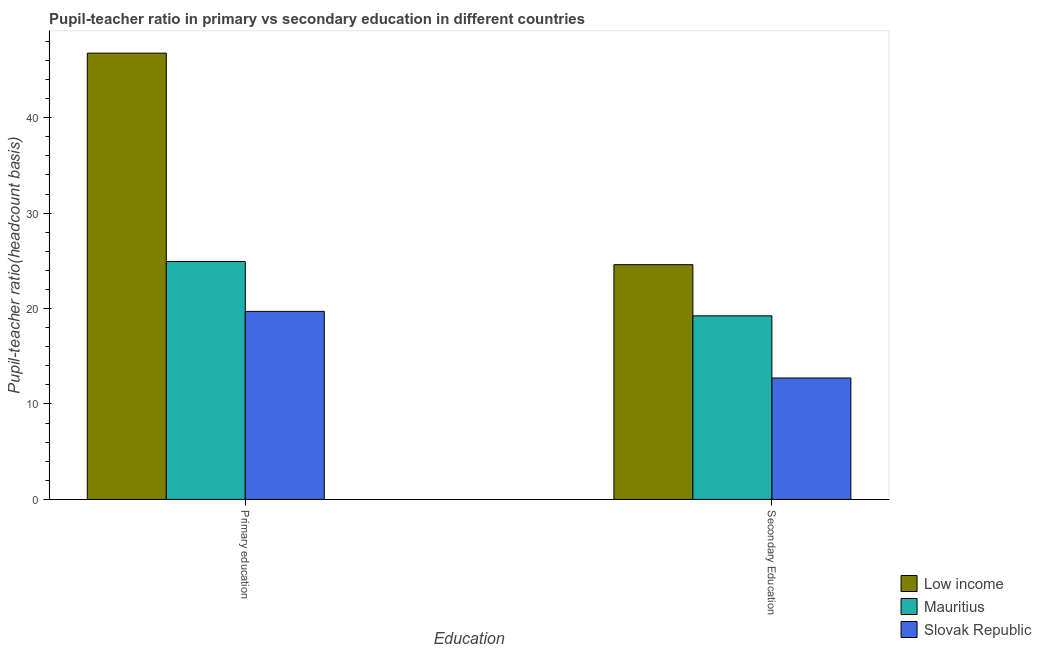How many groups of bars are there?
Provide a short and direct response. 2. Are the number of bars on each tick of the X-axis equal?
Your answer should be compact. Yes. How many bars are there on the 2nd tick from the right?
Your answer should be compact. 3. What is the label of the 2nd group of bars from the left?
Provide a succinct answer. Secondary Education. What is the pupil-teacher ratio in primary education in Slovak Republic?
Provide a succinct answer. 19.7. Across all countries, what is the maximum pupil-teacher ratio in primary education?
Give a very brief answer. 46.76. Across all countries, what is the minimum pupil-teacher ratio in primary education?
Give a very brief answer. 19.7. In which country was the pupil teacher ratio on secondary education maximum?
Make the answer very short. Low income. In which country was the pupil-teacher ratio in primary education minimum?
Ensure brevity in your answer.  Slovak Republic. What is the total pupil-teacher ratio in primary education in the graph?
Your answer should be compact. 91.39. What is the difference between the pupil teacher ratio on secondary education in Mauritius and that in Low income?
Make the answer very short. -5.36. What is the difference between the pupil teacher ratio on secondary education in Slovak Republic and the pupil-teacher ratio in primary education in Low income?
Your answer should be compact. -34.04. What is the average pupil-teacher ratio in primary education per country?
Offer a terse response. 30.46. What is the difference between the pupil teacher ratio on secondary education and pupil-teacher ratio in primary education in Low income?
Your answer should be very brief. -22.16. What is the ratio of the pupil teacher ratio on secondary education in Low income to that in Slovak Republic?
Your answer should be very brief. 1.93. Is the pupil-teacher ratio in primary education in Slovak Republic less than that in Low income?
Offer a terse response. Yes. What does the 1st bar from the right in Primary education represents?
Provide a succinct answer. Slovak Republic. How many countries are there in the graph?
Your response must be concise. 3. What is the difference between two consecutive major ticks on the Y-axis?
Your answer should be compact. 10. Does the graph contain any zero values?
Give a very brief answer. No. What is the title of the graph?
Keep it short and to the point. Pupil-teacher ratio in primary vs secondary education in different countries. Does "American Samoa" appear as one of the legend labels in the graph?
Your response must be concise. No. What is the label or title of the X-axis?
Give a very brief answer. Education. What is the label or title of the Y-axis?
Offer a very short reply. Pupil-teacher ratio(headcount basis). What is the Pupil-teacher ratio(headcount basis) in Low income in Primary education?
Offer a very short reply. 46.76. What is the Pupil-teacher ratio(headcount basis) in Mauritius in Primary education?
Make the answer very short. 24.93. What is the Pupil-teacher ratio(headcount basis) of Slovak Republic in Primary education?
Provide a short and direct response. 19.7. What is the Pupil-teacher ratio(headcount basis) of Low income in Secondary Education?
Provide a succinct answer. 24.6. What is the Pupil-teacher ratio(headcount basis) in Mauritius in Secondary Education?
Provide a succinct answer. 19.23. What is the Pupil-teacher ratio(headcount basis) in Slovak Republic in Secondary Education?
Your answer should be compact. 12.72. Across all Education, what is the maximum Pupil-teacher ratio(headcount basis) of Low income?
Offer a terse response. 46.76. Across all Education, what is the maximum Pupil-teacher ratio(headcount basis) of Mauritius?
Your answer should be very brief. 24.93. Across all Education, what is the maximum Pupil-teacher ratio(headcount basis) of Slovak Republic?
Your response must be concise. 19.7. Across all Education, what is the minimum Pupil-teacher ratio(headcount basis) of Low income?
Your answer should be very brief. 24.6. Across all Education, what is the minimum Pupil-teacher ratio(headcount basis) in Mauritius?
Offer a very short reply. 19.23. Across all Education, what is the minimum Pupil-teacher ratio(headcount basis) in Slovak Republic?
Your answer should be compact. 12.72. What is the total Pupil-teacher ratio(headcount basis) of Low income in the graph?
Give a very brief answer. 71.35. What is the total Pupil-teacher ratio(headcount basis) of Mauritius in the graph?
Offer a terse response. 44.16. What is the total Pupil-teacher ratio(headcount basis) in Slovak Republic in the graph?
Offer a very short reply. 32.43. What is the difference between the Pupil-teacher ratio(headcount basis) in Low income in Primary education and that in Secondary Education?
Provide a short and direct response. 22.16. What is the difference between the Pupil-teacher ratio(headcount basis) in Mauritius in Primary education and that in Secondary Education?
Your response must be concise. 5.69. What is the difference between the Pupil-teacher ratio(headcount basis) in Slovak Republic in Primary education and that in Secondary Education?
Your answer should be compact. 6.98. What is the difference between the Pupil-teacher ratio(headcount basis) in Low income in Primary education and the Pupil-teacher ratio(headcount basis) in Mauritius in Secondary Education?
Offer a terse response. 27.52. What is the difference between the Pupil-teacher ratio(headcount basis) in Low income in Primary education and the Pupil-teacher ratio(headcount basis) in Slovak Republic in Secondary Education?
Make the answer very short. 34.04. What is the difference between the Pupil-teacher ratio(headcount basis) in Mauritius in Primary education and the Pupil-teacher ratio(headcount basis) in Slovak Republic in Secondary Education?
Provide a succinct answer. 12.21. What is the average Pupil-teacher ratio(headcount basis) of Low income per Education?
Provide a succinct answer. 35.68. What is the average Pupil-teacher ratio(headcount basis) of Mauritius per Education?
Your answer should be compact. 22.08. What is the average Pupil-teacher ratio(headcount basis) in Slovak Republic per Education?
Ensure brevity in your answer.  16.21. What is the difference between the Pupil-teacher ratio(headcount basis) of Low income and Pupil-teacher ratio(headcount basis) of Mauritius in Primary education?
Offer a terse response. 21.83. What is the difference between the Pupil-teacher ratio(headcount basis) in Low income and Pupil-teacher ratio(headcount basis) in Slovak Republic in Primary education?
Give a very brief answer. 27.05. What is the difference between the Pupil-teacher ratio(headcount basis) in Mauritius and Pupil-teacher ratio(headcount basis) in Slovak Republic in Primary education?
Offer a terse response. 5.22. What is the difference between the Pupil-teacher ratio(headcount basis) of Low income and Pupil-teacher ratio(headcount basis) of Mauritius in Secondary Education?
Provide a short and direct response. 5.36. What is the difference between the Pupil-teacher ratio(headcount basis) in Low income and Pupil-teacher ratio(headcount basis) in Slovak Republic in Secondary Education?
Provide a short and direct response. 11.87. What is the difference between the Pupil-teacher ratio(headcount basis) in Mauritius and Pupil-teacher ratio(headcount basis) in Slovak Republic in Secondary Education?
Provide a succinct answer. 6.51. What is the ratio of the Pupil-teacher ratio(headcount basis) of Low income in Primary education to that in Secondary Education?
Provide a succinct answer. 1.9. What is the ratio of the Pupil-teacher ratio(headcount basis) in Mauritius in Primary education to that in Secondary Education?
Your response must be concise. 1.3. What is the ratio of the Pupil-teacher ratio(headcount basis) of Slovak Republic in Primary education to that in Secondary Education?
Your answer should be very brief. 1.55. What is the difference between the highest and the second highest Pupil-teacher ratio(headcount basis) in Low income?
Give a very brief answer. 22.16. What is the difference between the highest and the second highest Pupil-teacher ratio(headcount basis) of Mauritius?
Keep it short and to the point. 5.69. What is the difference between the highest and the second highest Pupil-teacher ratio(headcount basis) in Slovak Republic?
Your answer should be very brief. 6.98. What is the difference between the highest and the lowest Pupil-teacher ratio(headcount basis) of Low income?
Your answer should be compact. 22.16. What is the difference between the highest and the lowest Pupil-teacher ratio(headcount basis) of Mauritius?
Make the answer very short. 5.69. What is the difference between the highest and the lowest Pupil-teacher ratio(headcount basis) in Slovak Republic?
Your answer should be compact. 6.98. 